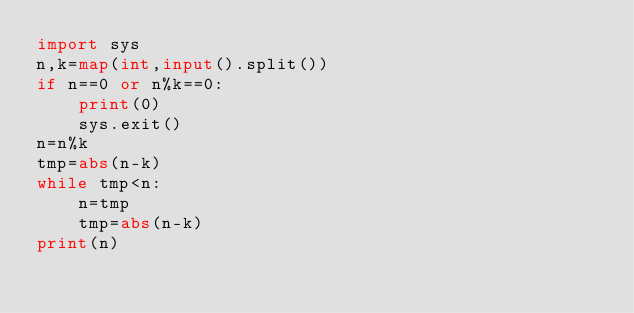Convert code to text. <code><loc_0><loc_0><loc_500><loc_500><_Python_>import sys
n,k=map(int,input().split())
if n==0 or n%k==0:
    print(0)
    sys.exit()
n=n%k
tmp=abs(n-k)
while tmp<n:
    n=tmp
    tmp=abs(n-k)
print(n)</code> 